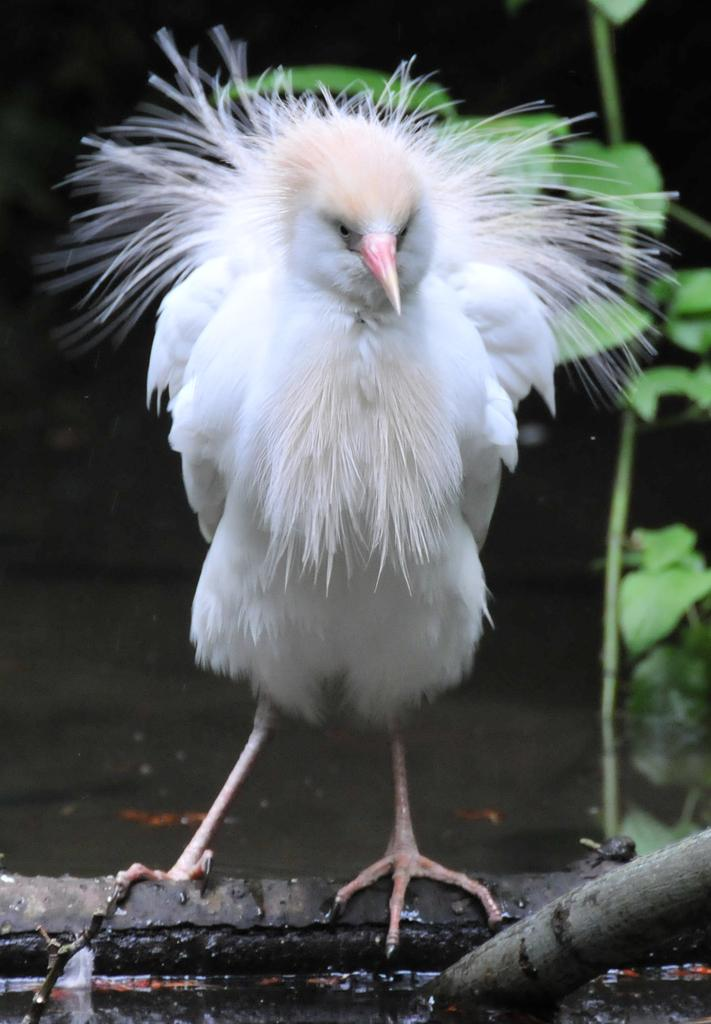What is the main subject of the image? There is a bird standing in the image. What can be seen in the background of the image? There is a branch with leaves in the background of the image. What is the bird standing on in the image? The bird is standing on water, which is visible in the image. What scientific theory is being demonstrated by the bird in the image? There is no scientific theory being demonstrated by the bird in the image. The image simply shows a bird standing on water. 